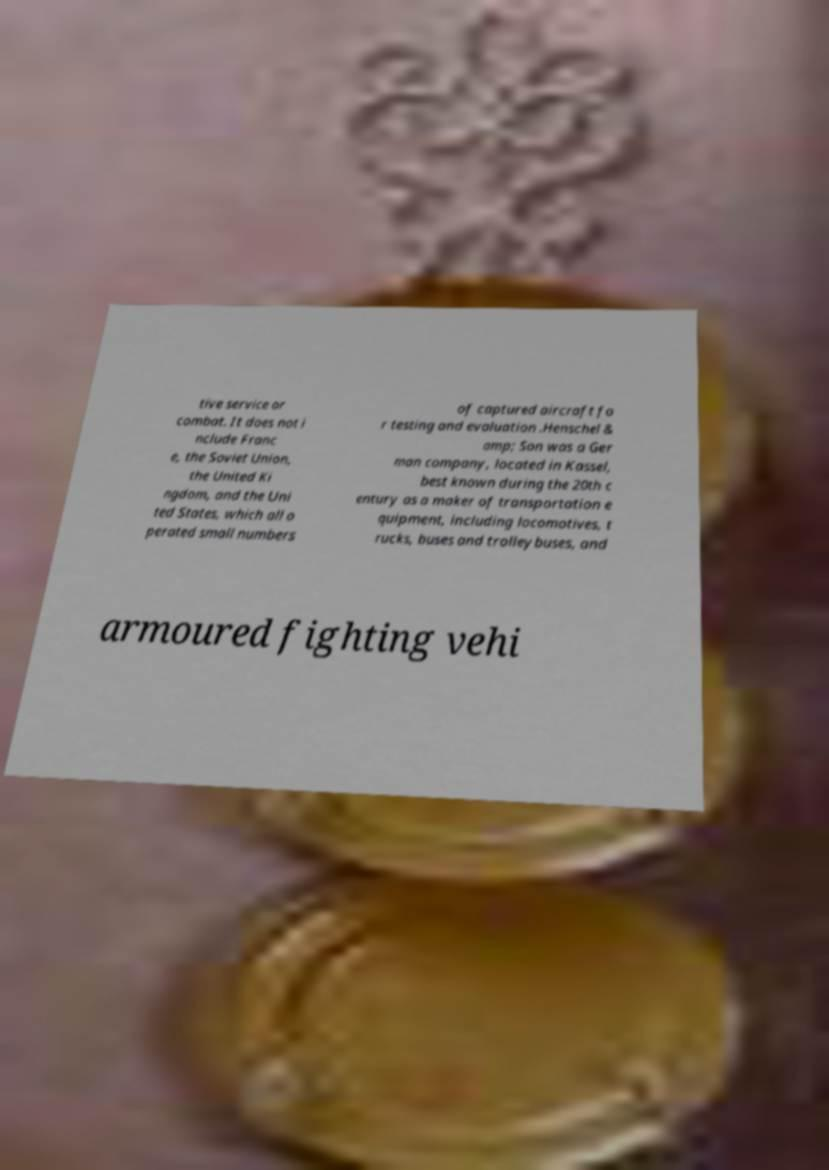Please read and relay the text visible in this image. What does it say? tive service or combat. It does not i nclude Franc e, the Soviet Union, the United Ki ngdom, and the Uni ted States, which all o perated small numbers of captured aircraft fo r testing and evaluation .Henschel & amp; Son was a Ger man company, located in Kassel, best known during the 20th c entury as a maker of transportation e quipment, including locomotives, t rucks, buses and trolleybuses, and armoured fighting vehi 